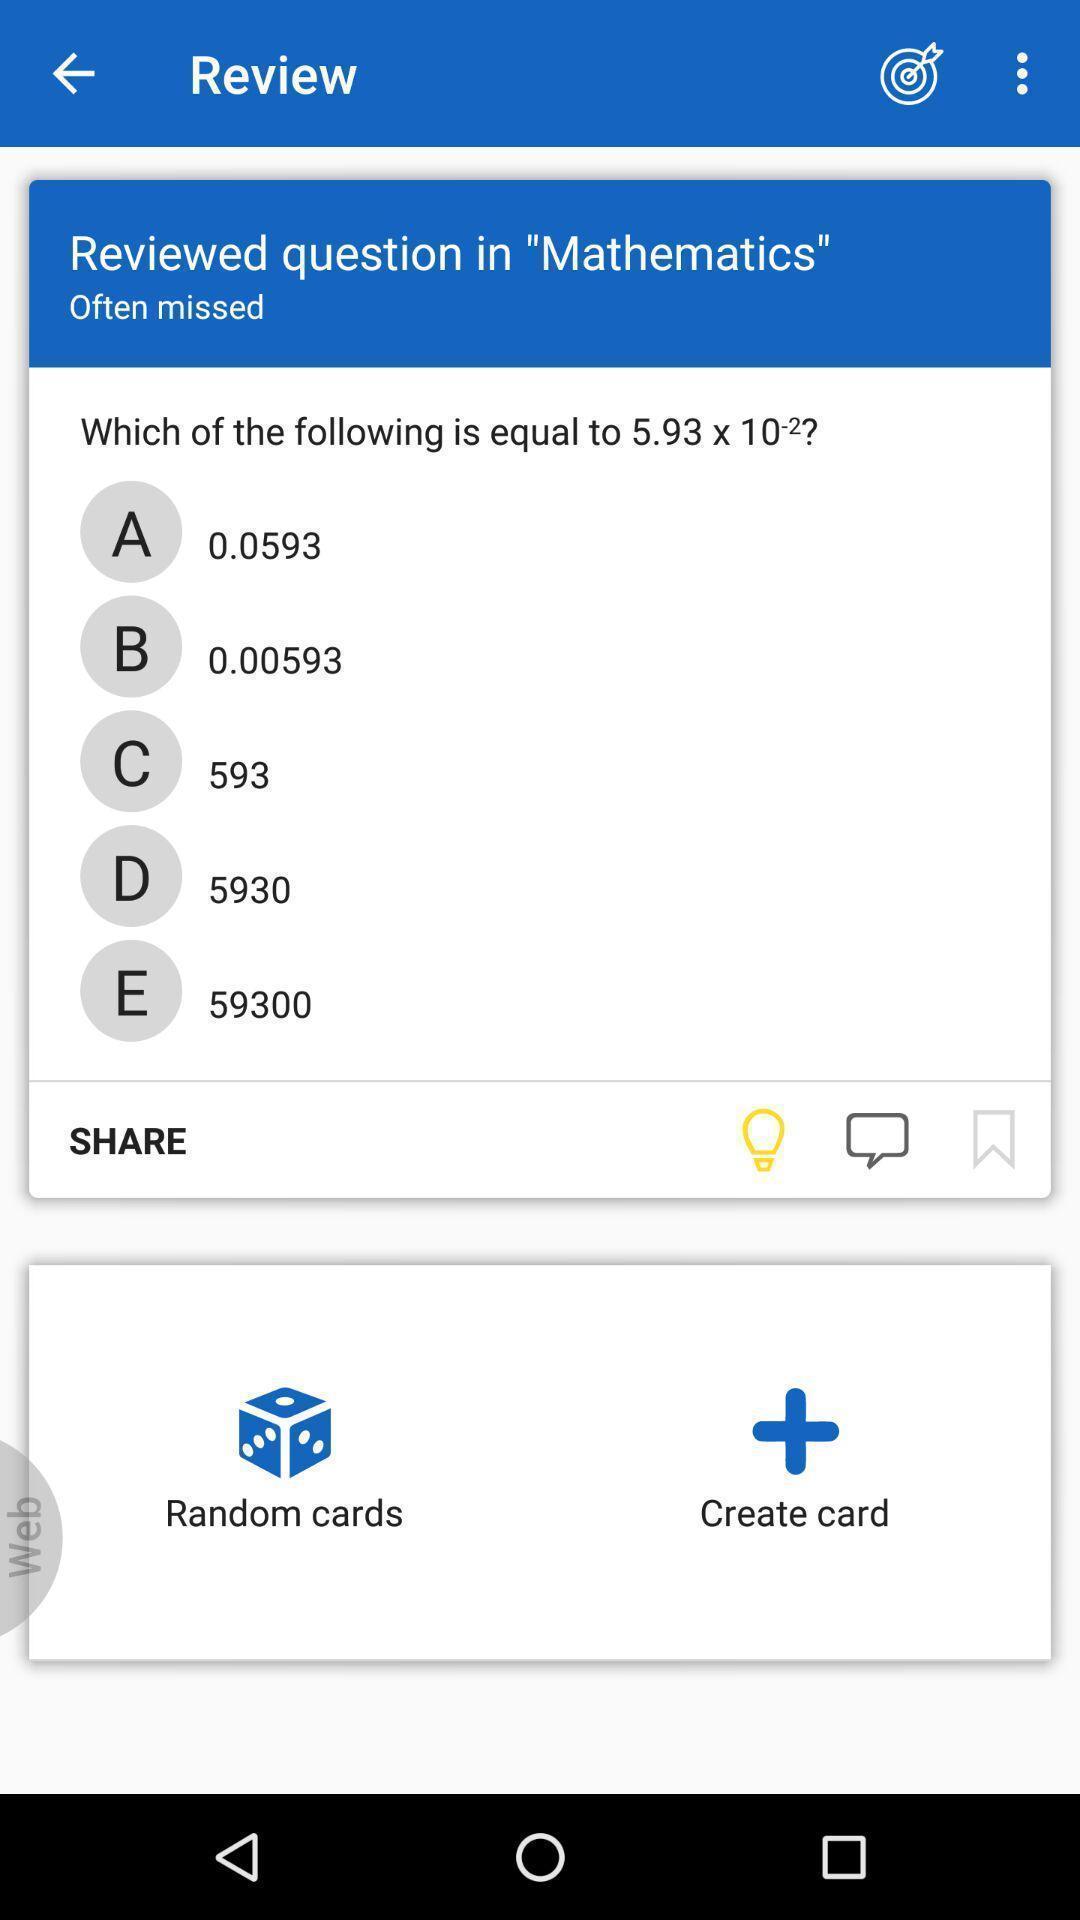What can you discern from this picture? Social app for solving maths. 